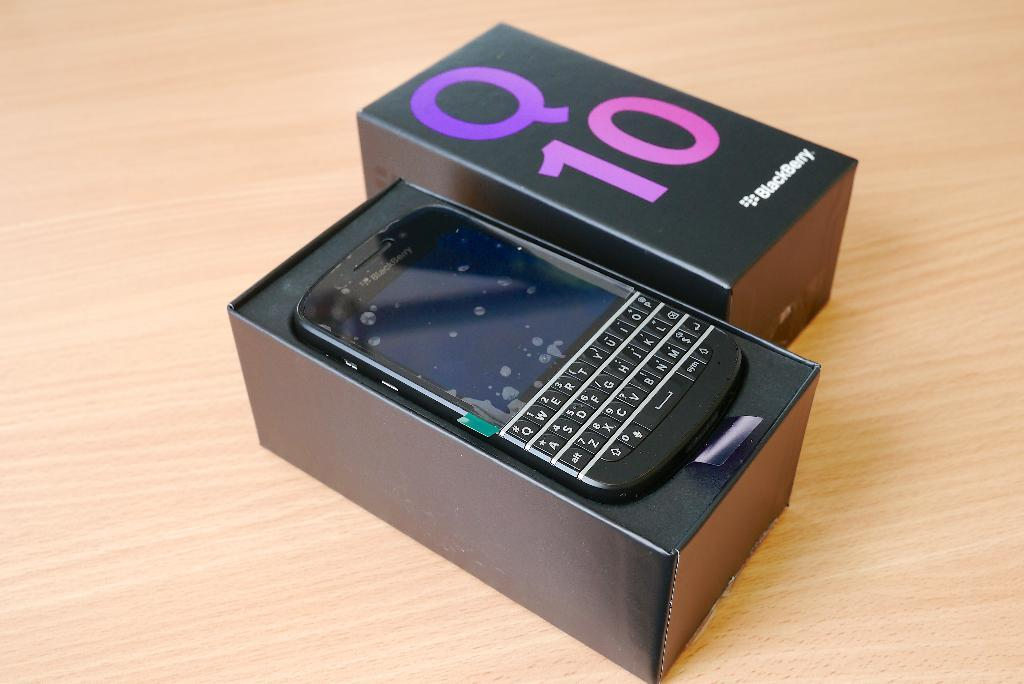<image>
Relay a brief, clear account of the picture shown. An open box containing a Blackberry Q10 cell phone. 